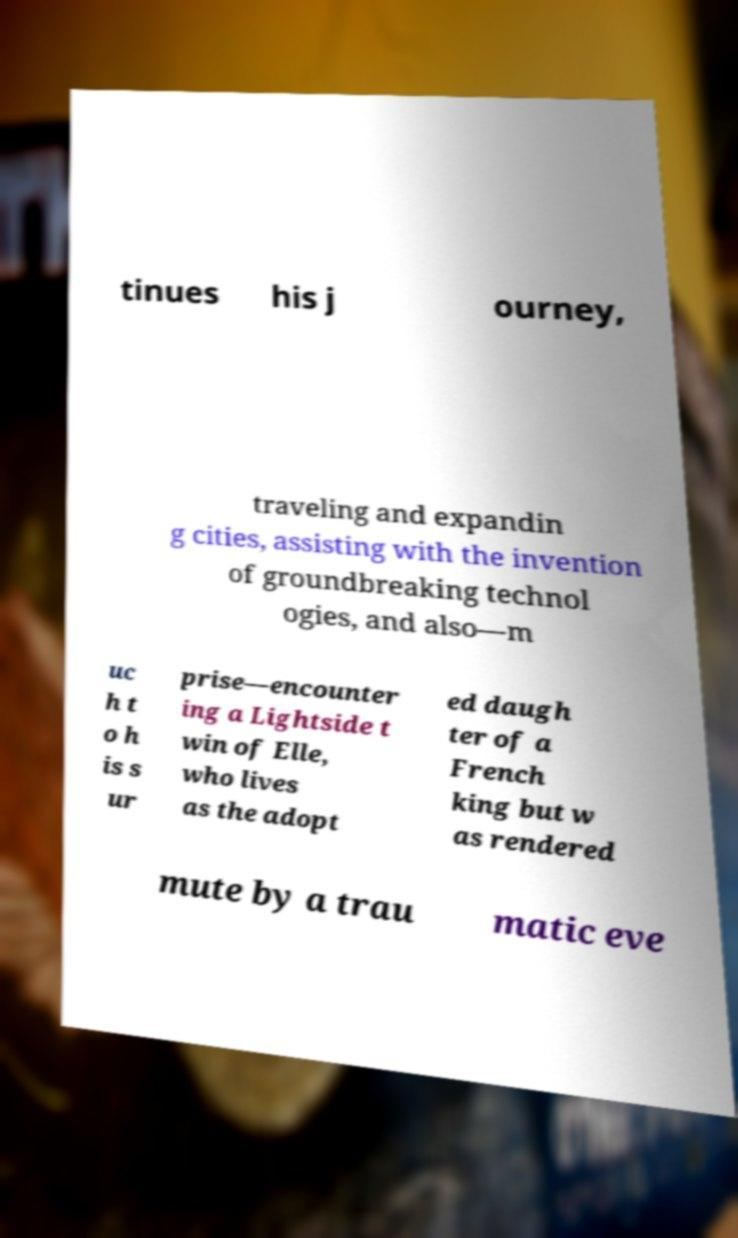I need the written content from this picture converted into text. Can you do that? tinues his j ourney, traveling and expandin g cities, assisting with the invention of groundbreaking technol ogies, and also—m uc h t o h is s ur prise—encounter ing a Lightside t win of Elle, who lives as the adopt ed daugh ter of a French king but w as rendered mute by a trau matic eve 